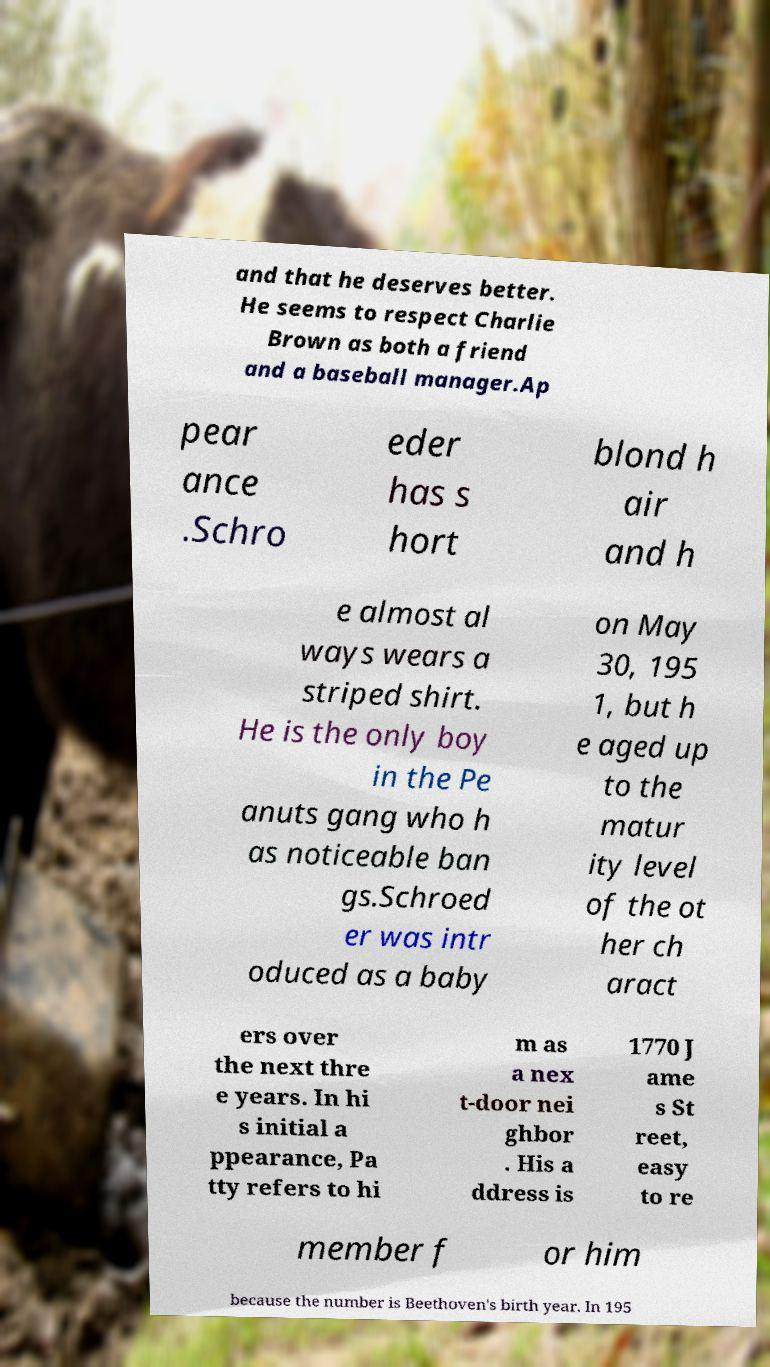Please read and relay the text visible in this image. What does it say? and that he deserves better. He seems to respect Charlie Brown as both a friend and a baseball manager.Ap pear ance .Schro eder has s hort blond h air and h e almost al ways wears a striped shirt. He is the only boy in the Pe anuts gang who h as noticeable ban gs.Schroed er was intr oduced as a baby on May 30, 195 1, but h e aged up to the matur ity level of the ot her ch aract ers over the next thre e years. In hi s initial a ppearance, Pa tty refers to hi m as a nex t-door nei ghbor . His a ddress is 1770 J ame s St reet, easy to re member f or him because the number is Beethoven's birth year. In 195 